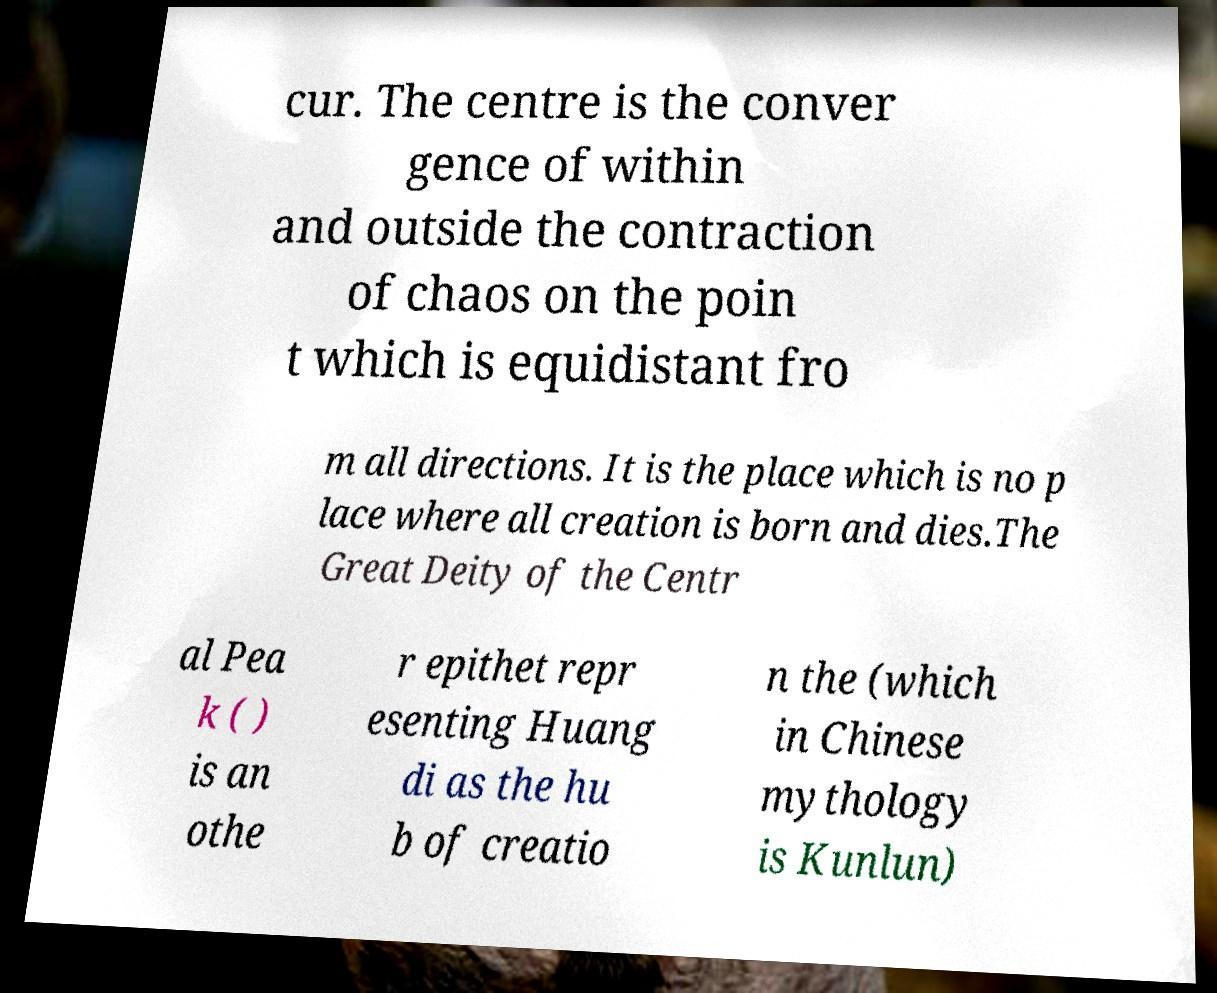Can you read and provide the text displayed in the image?This photo seems to have some interesting text. Can you extract and type it out for me? cur. The centre is the conver gence of within and outside the contraction of chaos on the poin t which is equidistant fro m all directions. It is the place which is no p lace where all creation is born and dies.The Great Deity of the Centr al Pea k ( ) is an othe r epithet repr esenting Huang di as the hu b of creatio n the (which in Chinese mythology is Kunlun) 